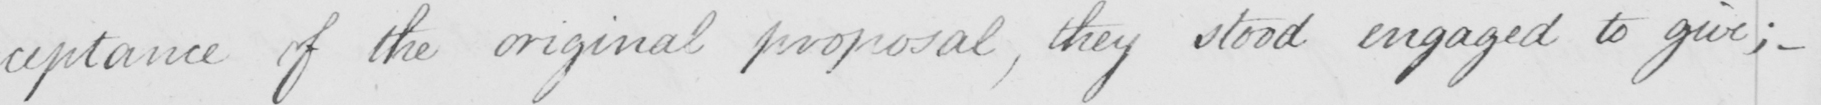Please provide the text content of this handwritten line. -ceptance of the original proposal , they stood engaged to give ;  _ 